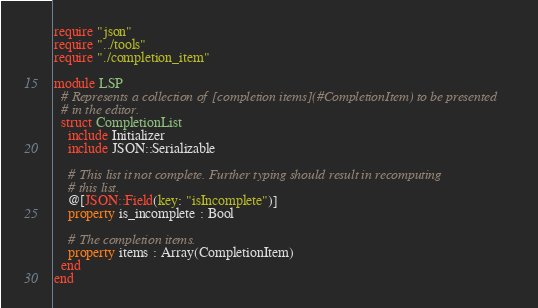Convert code to text. <code><loc_0><loc_0><loc_500><loc_500><_Crystal_>require "json"
require "../tools"
require "./completion_item"

module LSP
  # Represents a collection of [completion items](#CompletionItem) to be presented
  # in the editor.
  struct CompletionList
    include Initializer
    include JSON::Serializable

    # This list it not complete. Further typing should result in recomputing
    # this list.
    @[JSON::Field(key: "isIncomplete")]
    property is_incomplete : Bool

    # The completion items.
    property items : Array(CompletionItem)
  end
end
</code> 